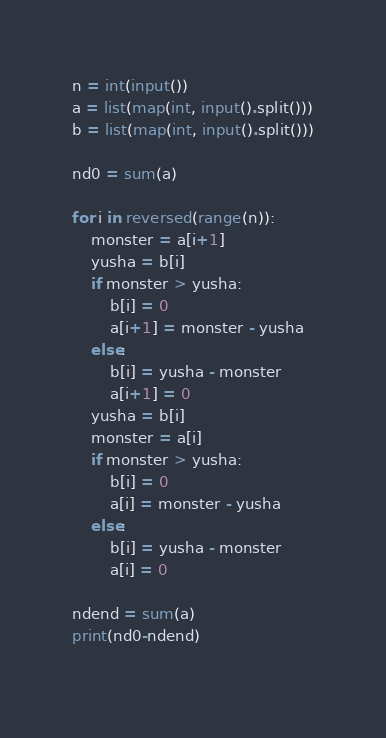Convert code to text. <code><loc_0><loc_0><loc_500><loc_500><_Python_>n = int(input())
a = list(map(int, input().split()))
b = list(map(int, input().split()))

nd0 = sum(a)

for i in reversed(range(n)):
    monster = a[i+1]
    yusha = b[i]
    if monster > yusha:
        b[i] = 0
        a[i+1] = monster - yusha
    else:
        b[i] = yusha - monster
        a[i+1] = 0
    yusha = b[i]
    monster = a[i]
    if monster > yusha:
        b[i] = 0
        a[i] = monster - yusha
    else:
        b[i] = yusha - monster
        a[i] = 0
        
ndend = sum(a)
print(nd0-ndend)
    </code> 